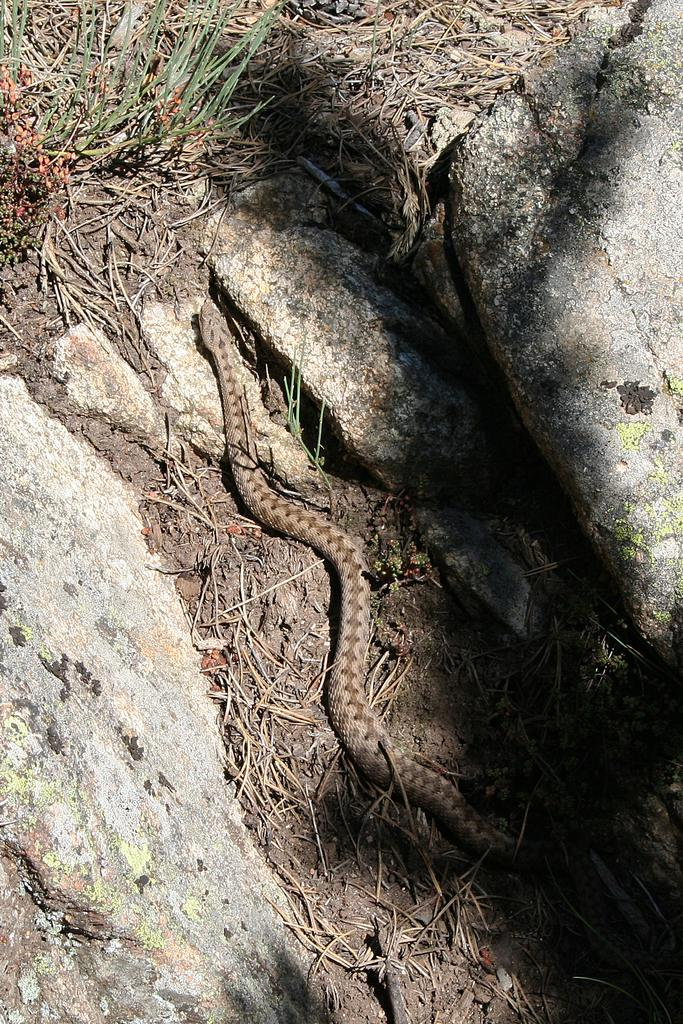What animal is present in the image? There is a snake in the image. What is the snake resting on? The snake is on the mud in the image. Are there any other objects or features in the image? Yes, there is grass on the mud and the snake is between rocks. What type of skirt is the snake wearing in the image? There is no skirt present in the image, as snakes do not wear clothing. 